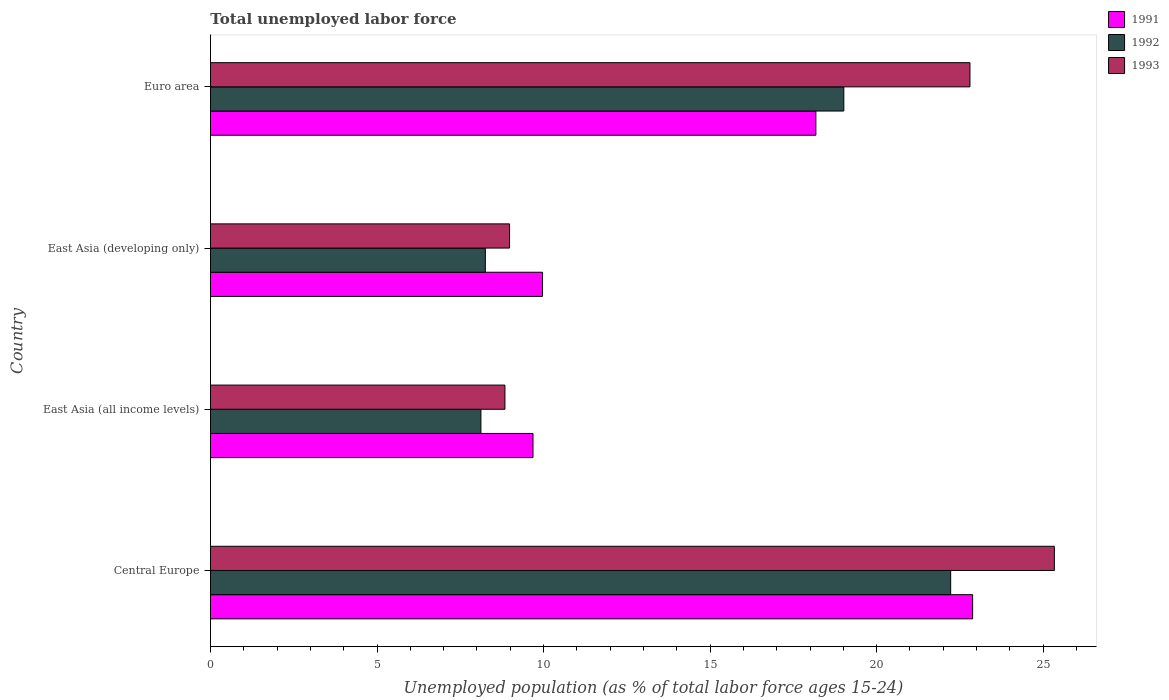How many groups of bars are there?
Make the answer very short. 4. Are the number of bars on each tick of the Y-axis equal?
Provide a short and direct response. Yes. How many bars are there on the 1st tick from the top?
Give a very brief answer. 3. How many bars are there on the 1st tick from the bottom?
Your answer should be compact. 3. What is the label of the 3rd group of bars from the top?
Provide a succinct answer. East Asia (all income levels). What is the percentage of unemployed population in in 1993 in Central Europe?
Your answer should be compact. 25.34. Across all countries, what is the maximum percentage of unemployed population in in 1993?
Make the answer very short. 25.34. Across all countries, what is the minimum percentage of unemployed population in in 1992?
Your answer should be compact. 8.12. In which country was the percentage of unemployed population in in 1991 maximum?
Keep it short and to the point. Central Europe. In which country was the percentage of unemployed population in in 1993 minimum?
Provide a succinct answer. East Asia (all income levels). What is the total percentage of unemployed population in in 1991 in the graph?
Ensure brevity in your answer.  60.71. What is the difference between the percentage of unemployed population in in 1992 in Central Europe and that in Euro area?
Make the answer very short. 3.21. What is the difference between the percentage of unemployed population in in 1992 in Euro area and the percentage of unemployed population in in 1993 in East Asia (all income levels)?
Keep it short and to the point. 10.17. What is the average percentage of unemployed population in in 1991 per country?
Give a very brief answer. 15.18. What is the difference between the percentage of unemployed population in in 1991 and percentage of unemployed population in in 1993 in Central Europe?
Ensure brevity in your answer.  -2.45. In how many countries, is the percentage of unemployed population in in 1991 greater than 20 %?
Provide a short and direct response. 1. What is the ratio of the percentage of unemployed population in in 1993 in Central Europe to that in Euro area?
Your answer should be compact. 1.11. What is the difference between the highest and the second highest percentage of unemployed population in in 1991?
Give a very brief answer. 4.71. What is the difference between the highest and the lowest percentage of unemployed population in in 1993?
Keep it short and to the point. 16.5. In how many countries, is the percentage of unemployed population in in 1993 greater than the average percentage of unemployed population in in 1993 taken over all countries?
Make the answer very short. 2. Is the sum of the percentage of unemployed population in in 1991 in Central Europe and Euro area greater than the maximum percentage of unemployed population in in 1993 across all countries?
Your response must be concise. Yes. What does the 3rd bar from the top in East Asia (all income levels) represents?
Your answer should be compact. 1991. What is the difference between two consecutive major ticks on the X-axis?
Your answer should be compact. 5. Where does the legend appear in the graph?
Make the answer very short. Top right. What is the title of the graph?
Offer a very short reply. Total unemployed labor force. Does "1966" appear as one of the legend labels in the graph?
Your answer should be compact. No. What is the label or title of the X-axis?
Your response must be concise. Unemployed population (as % of total labor force ages 15-24). What is the Unemployed population (as % of total labor force ages 15-24) in 1991 in Central Europe?
Offer a very short reply. 22.88. What is the Unemployed population (as % of total labor force ages 15-24) of 1992 in Central Europe?
Offer a terse response. 22.22. What is the Unemployed population (as % of total labor force ages 15-24) in 1993 in Central Europe?
Provide a short and direct response. 25.34. What is the Unemployed population (as % of total labor force ages 15-24) of 1991 in East Asia (all income levels)?
Provide a succinct answer. 9.68. What is the Unemployed population (as % of total labor force ages 15-24) of 1992 in East Asia (all income levels)?
Your response must be concise. 8.12. What is the Unemployed population (as % of total labor force ages 15-24) of 1993 in East Asia (all income levels)?
Provide a succinct answer. 8.84. What is the Unemployed population (as % of total labor force ages 15-24) in 1991 in East Asia (developing only)?
Offer a terse response. 9.97. What is the Unemployed population (as % of total labor force ages 15-24) of 1992 in East Asia (developing only)?
Your answer should be compact. 8.25. What is the Unemployed population (as % of total labor force ages 15-24) of 1993 in East Asia (developing only)?
Give a very brief answer. 8.98. What is the Unemployed population (as % of total labor force ages 15-24) in 1991 in Euro area?
Make the answer very short. 18.18. What is the Unemployed population (as % of total labor force ages 15-24) in 1992 in Euro area?
Provide a succinct answer. 19.01. What is the Unemployed population (as % of total labor force ages 15-24) in 1993 in Euro area?
Provide a short and direct response. 22.8. Across all countries, what is the maximum Unemployed population (as % of total labor force ages 15-24) in 1991?
Give a very brief answer. 22.88. Across all countries, what is the maximum Unemployed population (as % of total labor force ages 15-24) of 1992?
Ensure brevity in your answer.  22.22. Across all countries, what is the maximum Unemployed population (as % of total labor force ages 15-24) in 1993?
Offer a very short reply. 25.34. Across all countries, what is the minimum Unemployed population (as % of total labor force ages 15-24) of 1991?
Keep it short and to the point. 9.68. Across all countries, what is the minimum Unemployed population (as % of total labor force ages 15-24) in 1992?
Give a very brief answer. 8.12. Across all countries, what is the minimum Unemployed population (as % of total labor force ages 15-24) in 1993?
Ensure brevity in your answer.  8.84. What is the total Unemployed population (as % of total labor force ages 15-24) of 1991 in the graph?
Your answer should be very brief. 60.71. What is the total Unemployed population (as % of total labor force ages 15-24) in 1992 in the graph?
Ensure brevity in your answer.  57.61. What is the total Unemployed population (as % of total labor force ages 15-24) in 1993 in the graph?
Provide a succinct answer. 65.96. What is the difference between the Unemployed population (as % of total labor force ages 15-24) in 1991 in Central Europe and that in East Asia (all income levels)?
Your answer should be very brief. 13.2. What is the difference between the Unemployed population (as % of total labor force ages 15-24) in 1992 in Central Europe and that in East Asia (all income levels)?
Provide a short and direct response. 14.1. What is the difference between the Unemployed population (as % of total labor force ages 15-24) of 1993 in Central Europe and that in East Asia (all income levels)?
Give a very brief answer. 16.5. What is the difference between the Unemployed population (as % of total labor force ages 15-24) of 1991 in Central Europe and that in East Asia (developing only)?
Make the answer very short. 12.91. What is the difference between the Unemployed population (as % of total labor force ages 15-24) of 1992 in Central Europe and that in East Asia (developing only)?
Keep it short and to the point. 13.97. What is the difference between the Unemployed population (as % of total labor force ages 15-24) in 1993 in Central Europe and that in East Asia (developing only)?
Your response must be concise. 16.36. What is the difference between the Unemployed population (as % of total labor force ages 15-24) in 1991 in Central Europe and that in Euro area?
Keep it short and to the point. 4.71. What is the difference between the Unemployed population (as % of total labor force ages 15-24) of 1992 in Central Europe and that in Euro area?
Ensure brevity in your answer.  3.21. What is the difference between the Unemployed population (as % of total labor force ages 15-24) of 1993 in Central Europe and that in Euro area?
Give a very brief answer. 2.53. What is the difference between the Unemployed population (as % of total labor force ages 15-24) in 1991 in East Asia (all income levels) and that in East Asia (developing only)?
Provide a succinct answer. -0.29. What is the difference between the Unemployed population (as % of total labor force ages 15-24) in 1992 in East Asia (all income levels) and that in East Asia (developing only)?
Provide a short and direct response. -0.13. What is the difference between the Unemployed population (as % of total labor force ages 15-24) of 1993 in East Asia (all income levels) and that in East Asia (developing only)?
Your answer should be very brief. -0.14. What is the difference between the Unemployed population (as % of total labor force ages 15-24) in 1991 in East Asia (all income levels) and that in Euro area?
Keep it short and to the point. -8.49. What is the difference between the Unemployed population (as % of total labor force ages 15-24) of 1992 in East Asia (all income levels) and that in Euro area?
Offer a very short reply. -10.9. What is the difference between the Unemployed population (as % of total labor force ages 15-24) in 1993 in East Asia (all income levels) and that in Euro area?
Keep it short and to the point. -13.96. What is the difference between the Unemployed population (as % of total labor force ages 15-24) in 1991 in East Asia (developing only) and that in Euro area?
Your response must be concise. -8.21. What is the difference between the Unemployed population (as % of total labor force ages 15-24) of 1992 in East Asia (developing only) and that in Euro area?
Your answer should be very brief. -10.76. What is the difference between the Unemployed population (as % of total labor force ages 15-24) of 1993 in East Asia (developing only) and that in Euro area?
Ensure brevity in your answer.  -13.82. What is the difference between the Unemployed population (as % of total labor force ages 15-24) in 1991 in Central Europe and the Unemployed population (as % of total labor force ages 15-24) in 1992 in East Asia (all income levels)?
Your response must be concise. 14.76. What is the difference between the Unemployed population (as % of total labor force ages 15-24) in 1991 in Central Europe and the Unemployed population (as % of total labor force ages 15-24) in 1993 in East Asia (all income levels)?
Provide a short and direct response. 14.04. What is the difference between the Unemployed population (as % of total labor force ages 15-24) of 1992 in Central Europe and the Unemployed population (as % of total labor force ages 15-24) of 1993 in East Asia (all income levels)?
Your answer should be very brief. 13.38. What is the difference between the Unemployed population (as % of total labor force ages 15-24) of 1991 in Central Europe and the Unemployed population (as % of total labor force ages 15-24) of 1992 in East Asia (developing only)?
Your answer should be very brief. 14.63. What is the difference between the Unemployed population (as % of total labor force ages 15-24) in 1991 in Central Europe and the Unemployed population (as % of total labor force ages 15-24) in 1993 in East Asia (developing only)?
Provide a succinct answer. 13.9. What is the difference between the Unemployed population (as % of total labor force ages 15-24) of 1992 in Central Europe and the Unemployed population (as % of total labor force ages 15-24) of 1993 in East Asia (developing only)?
Your answer should be compact. 13.24. What is the difference between the Unemployed population (as % of total labor force ages 15-24) of 1991 in Central Europe and the Unemployed population (as % of total labor force ages 15-24) of 1992 in Euro area?
Give a very brief answer. 3.87. What is the difference between the Unemployed population (as % of total labor force ages 15-24) of 1991 in Central Europe and the Unemployed population (as % of total labor force ages 15-24) of 1993 in Euro area?
Provide a succinct answer. 0.08. What is the difference between the Unemployed population (as % of total labor force ages 15-24) in 1992 in Central Europe and the Unemployed population (as % of total labor force ages 15-24) in 1993 in Euro area?
Your answer should be very brief. -0.58. What is the difference between the Unemployed population (as % of total labor force ages 15-24) in 1991 in East Asia (all income levels) and the Unemployed population (as % of total labor force ages 15-24) in 1992 in East Asia (developing only)?
Ensure brevity in your answer.  1.43. What is the difference between the Unemployed population (as % of total labor force ages 15-24) in 1991 in East Asia (all income levels) and the Unemployed population (as % of total labor force ages 15-24) in 1993 in East Asia (developing only)?
Your answer should be compact. 0.7. What is the difference between the Unemployed population (as % of total labor force ages 15-24) in 1992 in East Asia (all income levels) and the Unemployed population (as % of total labor force ages 15-24) in 1993 in East Asia (developing only)?
Your answer should be very brief. -0.86. What is the difference between the Unemployed population (as % of total labor force ages 15-24) of 1991 in East Asia (all income levels) and the Unemployed population (as % of total labor force ages 15-24) of 1992 in Euro area?
Provide a short and direct response. -9.33. What is the difference between the Unemployed population (as % of total labor force ages 15-24) of 1991 in East Asia (all income levels) and the Unemployed population (as % of total labor force ages 15-24) of 1993 in Euro area?
Your answer should be very brief. -13.12. What is the difference between the Unemployed population (as % of total labor force ages 15-24) in 1992 in East Asia (all income levels) and the Unemployed population (as % of total labor force ages 15-24) in 1993 in Euro area?
Offer a terse response. -14.68. What is the difference between the Unemployed population (as % of total labor force ages 15-24) in 1991 in East Asia (developing only) and the Unemployed population (as % of total labor force ages 15-24) in 1992 in Euro area?
Give a very brief answer. -9.05. What is the difference between the Unemployed population (as % of total labor force ages 15-24) of 1991 in East Asia (developing only) and the Unemployed population (as % of total labor force ages 15-24) of 1993 in Euro area?
Provide a short and direct response. -12.83. What is the difference between the Unemployed population (as % of total labor force ages 15-24) of 1992 in East Asia (developing only) and the Unemployed population (as % of total labor force ages 15-24) of 1993 in Euro area?
Your answer should be very brief. -14.55. What is the average Unemployed population (as % of total labor force ages 15-24) in 1991 per country?
Your answer should be compact. 15.18. What is the average Unemployed population (as % of total labor force ages 15-24) of 1992 per country?
Your answer should be compact. 14.4. What is the average Unemployed population (as % of total labor force ages 15-24) of 1993 per country?
Provide a succinct answer. 16.49. What is the difference between the Unemployed population (as % of total labor force ages 15-24) of 1991 and Unemployed population (as % of total labor force ages 15-24) of 1992 in Central Europe?
Offer a very short reply. 0.66. What is the difference between the Unemployed population (as % of total labor force ages 15-24) of 1991 and Unemployed population (as % of total labor force ages 15-24) of 1993 in Central Europe?
Keep it short and to the point. -2.45. What is the difference between the Unemployed population (as % of total labor force ages 15-24) in 1992 and Unemployed population (as % of total labor force ages 15-24) in 1993 in Central Europe?
Provide a succinct answer. -3.11. What is the difference between the Unemployed population (as % of total labor force ages 15-24) in 1991 and Unemployed population (as % of total labor force ages 15-24) in 1992 in East Asia (all income levels)?
Ensure brevity in your answer.  1.56. What is the difference between the Unemployed population (as % of total labor force ages 15-24) of 1991 and Unemployed population (as % of total labor force ages 15-24) of 1993 in East Asia (all income levels)?
Make the answer very short. 0.84. What is the difference between the Unemployed population (as % of total labor force ages 15-24) of 1992 and Unemployed population (as % of total labor force ages 15-24) of 1993 in East Asia (all income levels)?
Your response must be concise. -0.72. What is the difference between the Unemployed population (as % of total labor force ages 15-24) in 1991 and Unemployed population (as % of total labor force ages 15-24) in 1992 in East Asia (developing only)?
Give a very brief answer. 1.72. What is the difference between the Unemployed population (as % of total labor force ages 15-24) in 1992 and Unemployed population (as % of total labor force ages 15-24) in 1993 in East Asia (developing only)?
Offer a terse response. -0.73. What is the difference between the Unemployed population (as % of total labor force ages 15-24) of 1991 and Unemployed population (as % of total labor force ages 15-24) of 1992 in Euro area?
Offer a terse response. -0.84. What is the difference between the Unemployed population (as % of total labor force ages 15-24) of 1991 and Unemployed population (as % of total labor force ages 15-24) of 1993 in Euro area?
Provide a short and direct response. -4.63. What is the difference between the Unemployed population (as % of total labor force ages 15-24) in 1992 and Unemployed population (as % of total labor force ages 15-24) in 1993 in Euro area?
Keep it short and to the point. -3.79. What is the ratio of the Unemployed population (as % of total labor force ages 15-24) in 1991 in Central Europe to that in East Asia (all income levels)?
Provide a short and direct response. 2.36. What is the ratio of the Unemployed population (as % of total labor force ages 15-24) of 1992 in Central Europe to that in East Asia (all income levels)?
Provide a succinct answer. 2.74. What is the ratio of the Unemployed population (as % of total labor force ages 15-24) of 1993 in Central Europe to that in East Asia (all income levels)?
Provide a succinct answer. 2.87. What is the ratio of the Unemployed population (as % of total labor force ages 15-24) in 1991 in Central Europe to that in East Asia (developing only)?
Your response must be concise. 2.3. What is the ratio of the Unemployed population (as % of total labor force ages 15-24) in 1992 in Central Europe to that in East Asia (developing only)?
Offer a terse response. 2.69. What is the ratio of the Unemployed population (as % of total labor force ages 15-24) of 1993 in Central Europe to that in East Asia (developing only)?
Give a very brief answer. 2.82. What is the ratio of the Unemployed population (as % of total labor force ages 15-24) of 1991 in Central Europe to that in Euro area?
Keep it short and to the point. 1.26. What is the ratio of the Unemployed population (as % of total labor force ages 15-24) in 1992 in Central Europe to that in Euro area?
Offer a very short reply. 1.17. What is the ratio of the Unemployed population (as % of total labor force ages 15-24) of 1993 in Central Europe to that in Euro area?
Your answer should be very brief. 1.11. What is the ratio of the Unemployed population (as % of total labor force ages 15-24) in 1991 in East Asia (all income levels) to that in East Asia (developing only)?
Offer a very short reply. 0.97. What is the ratio of the Unemployed population (as % of total labor force ages 15-24) of 1992 in East Asia (all income levels) to that in East Asia (developing only)?
Provide a short and direct response. 0.98. What is the ratio of the Unemployed population (as % of total labor force ages 15-24) of 1993 in East Asia (all income levels) to that in East Asia (developing only)?
Your answer should be very brief. 0.98. What is the ratio of the Unemployed population (as % of total labor force ages 15-24) in 1991 in East Asia (all income levels) to that in Euro area?
Offer a very short reply. 0.53. What is the ratio of the Unemployed population (as % of total labor force ages 15-24) of 1992 in East Asia (all income levels) to that in Euro area?
Provide a short and direct response. 0.43. What is the ratio of the Unemployed population (as % of total labor force ages 15-24) in 1993 in East Asia (all income levels) to that in Euro area?
Your response must be concise. 0.39. What is the ratio of the Unemployed population (as % of total labor force ages 15-24) in 1991 in East Asia (developing only) to that in Euro area?
Your answer should be compact. 0.55. What is the ratio of the Unemployed population (as % of total labor force ages 15-24) in 1992 in East Asia (developing only) to that in Euro area?
Make the answer very short. 0.43. What is the ratio of the Unemployed population (as % of total labor force ages 15-24) of 1993 in East Asia (developing only) to that in Euro area?
Your answer should be compact. 0.39. What is the difference between the highest and the second highest Unemployed population (as % of total labor force ages 15-24) in 1991?
Provide a succinct answer. 4.71. What is the difference between the highest and the second highest Unemployed population (as % of total labor force ages 15-24) of 1992?
Keep it short and to the point. 3.21. What is the difference between the highest and the second highest Unemployed population (as % of total labor force ages 15-24) of 1993?
Provide a short and direct response. 2.53. What is the difference between the highest and the lowest Unemployed population (as % of total labor force ages 15-24) of 1991?
Provide a short and direct response. 13.2. What is the difference between the highest and the lowest Unemployed population (as % of total labor force ages 15-24) in 1992?
Your response must be concise. 14.1. What is the difference between the highest and the lowest Unemployed population (as % of total labor force ages 15-24) in 1993?
Your response must be concise. 16.5. 